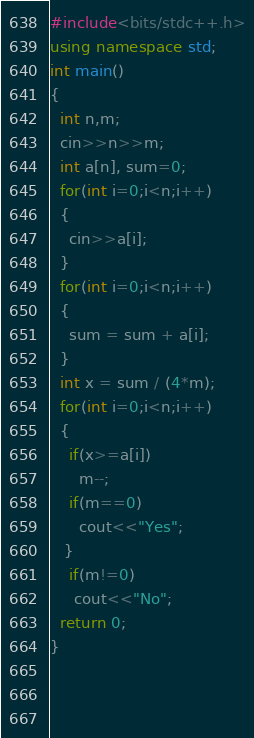<code> <loc_0><loc_0><loc_500><loc_500><_C++_>#include<bits/stdc++.h>
using namespace std;
int main()
{
  int n,m;
  cin>>n>>m;
  int a[n], sum=0;
  for(int i=0;i<n;i++)
  {
    cin>>a[i];
  }
  for(int i=0;i<n;i++)
  { 
    sum = sum + a[i];
  }
  int x = sum / (4*m);
  for(int i=0;i<n;i++)
  {
    if(x>=a[i])
      m--;
    if(m==0)
      cout<<"Yes";
   }
    if(m!=0)
     cout<<"No";
  return 0;
}
  
  
  </code> 